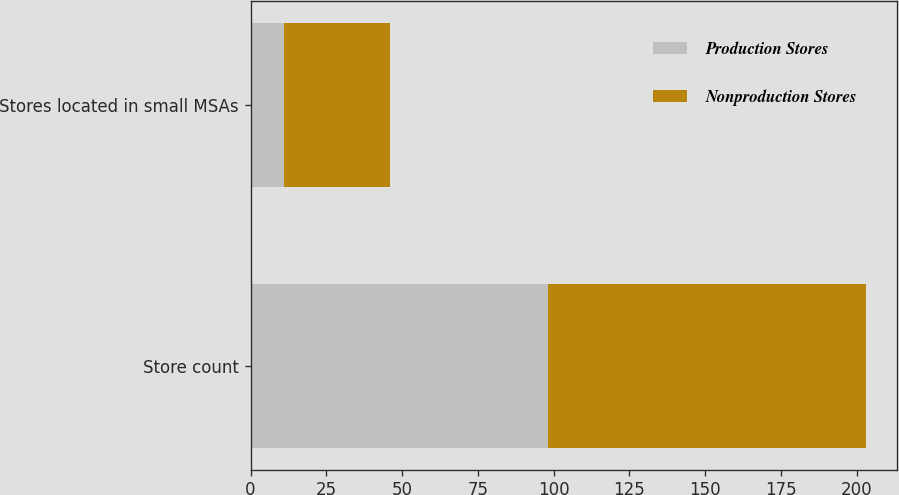<chart> <loc_0><loc_0><loc_500><loc_500><stacked_bar_chart><ecel><fcel>Store count<fcel>Stores located in small MSAs<nl><fcel>Production Stores<fcel>98<fcel>11<nl><fcel>Nonproduction Stores<fcel>105<fcel>35<nl></chart> 